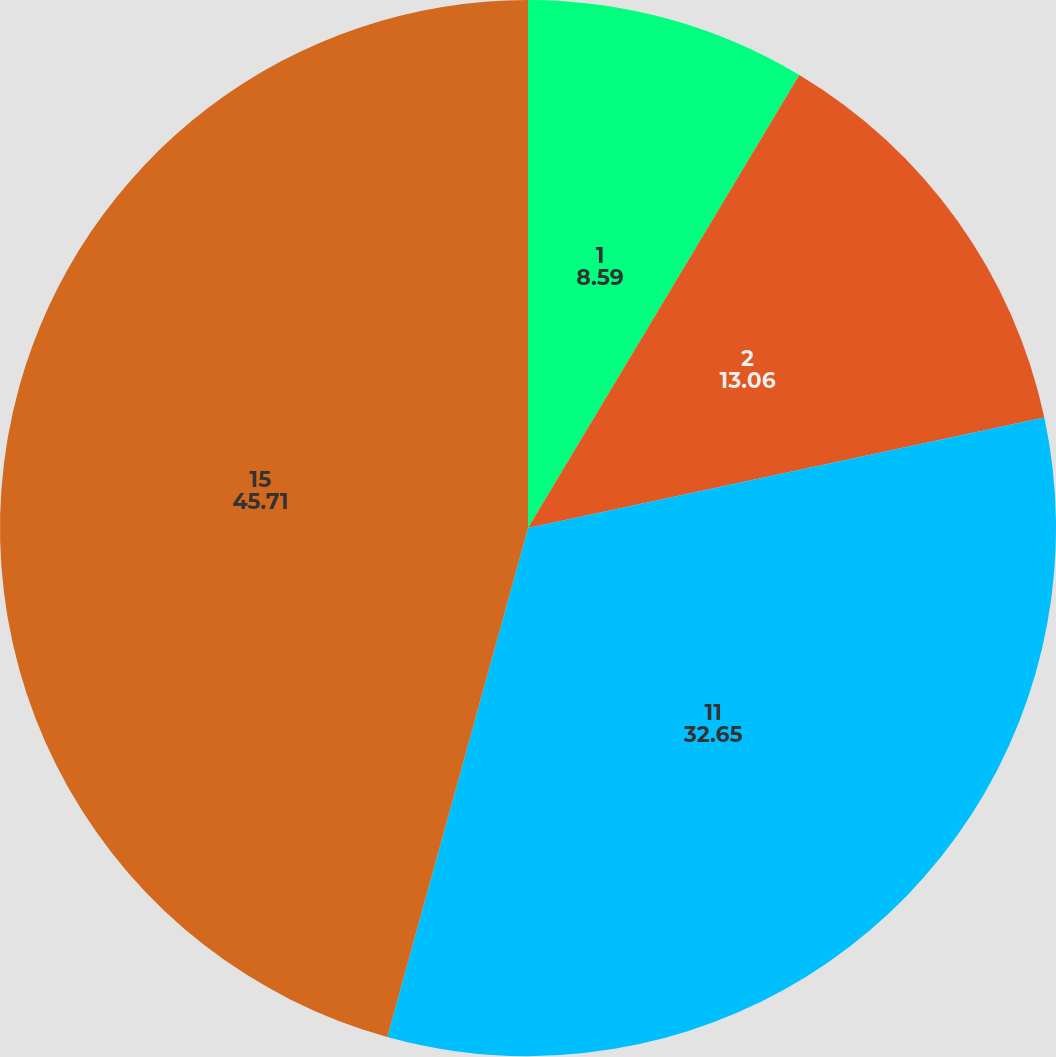<chart> <loc_0><loc_0><loc_500><loc_500><pie_chart><fcel>1<fcel>2<fcel>11<fcel>15<nl><fcel>8.59%<fcel>13.06%<fcel>32.65%<fcel>45.71%<nl></chart> 